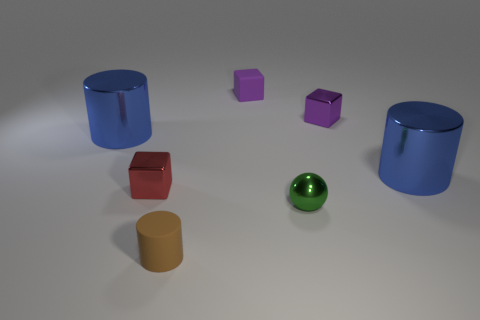Add 1 small blocks. How many objects exist? 8 Subtract all blocks. How many objects are left? 4 Add 7 red metallic objects. How many red metallic objects exist? 8 Subtract 1 green balls. How many objects are left? 6 Subtract all blue shiny objects. Subtract all red blocks. How many objects are left? 4 Add 3 small green metal balls. How many small green metal balls are left? 4 